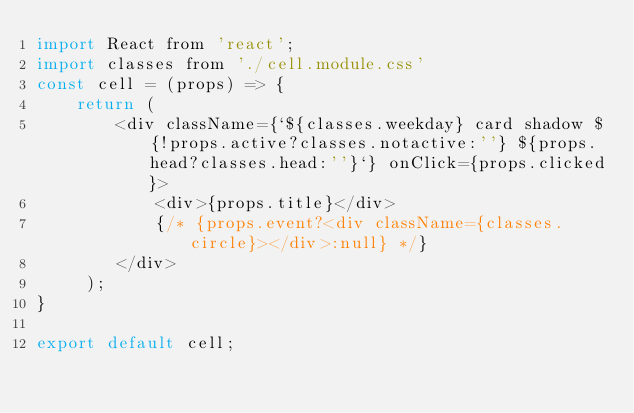<code> <loc_0><loc_0><loc_500><loc_500><_JavaScript_>import React from 'react';
import classes from './cell.module.css'
const cell = (props) => {
	return ( 
		<div className={`${classes.weekday} card shadow ${!props.active?classes.notactive:''} ${props.head?classes.head:''}`} onClick={props.clicked}>
			<div>{props.title}</div>
			{/* {props.event?<div className={classes.circle}></div>:null} */}
		</div>
	 );
}
 
export default cell;</code> 